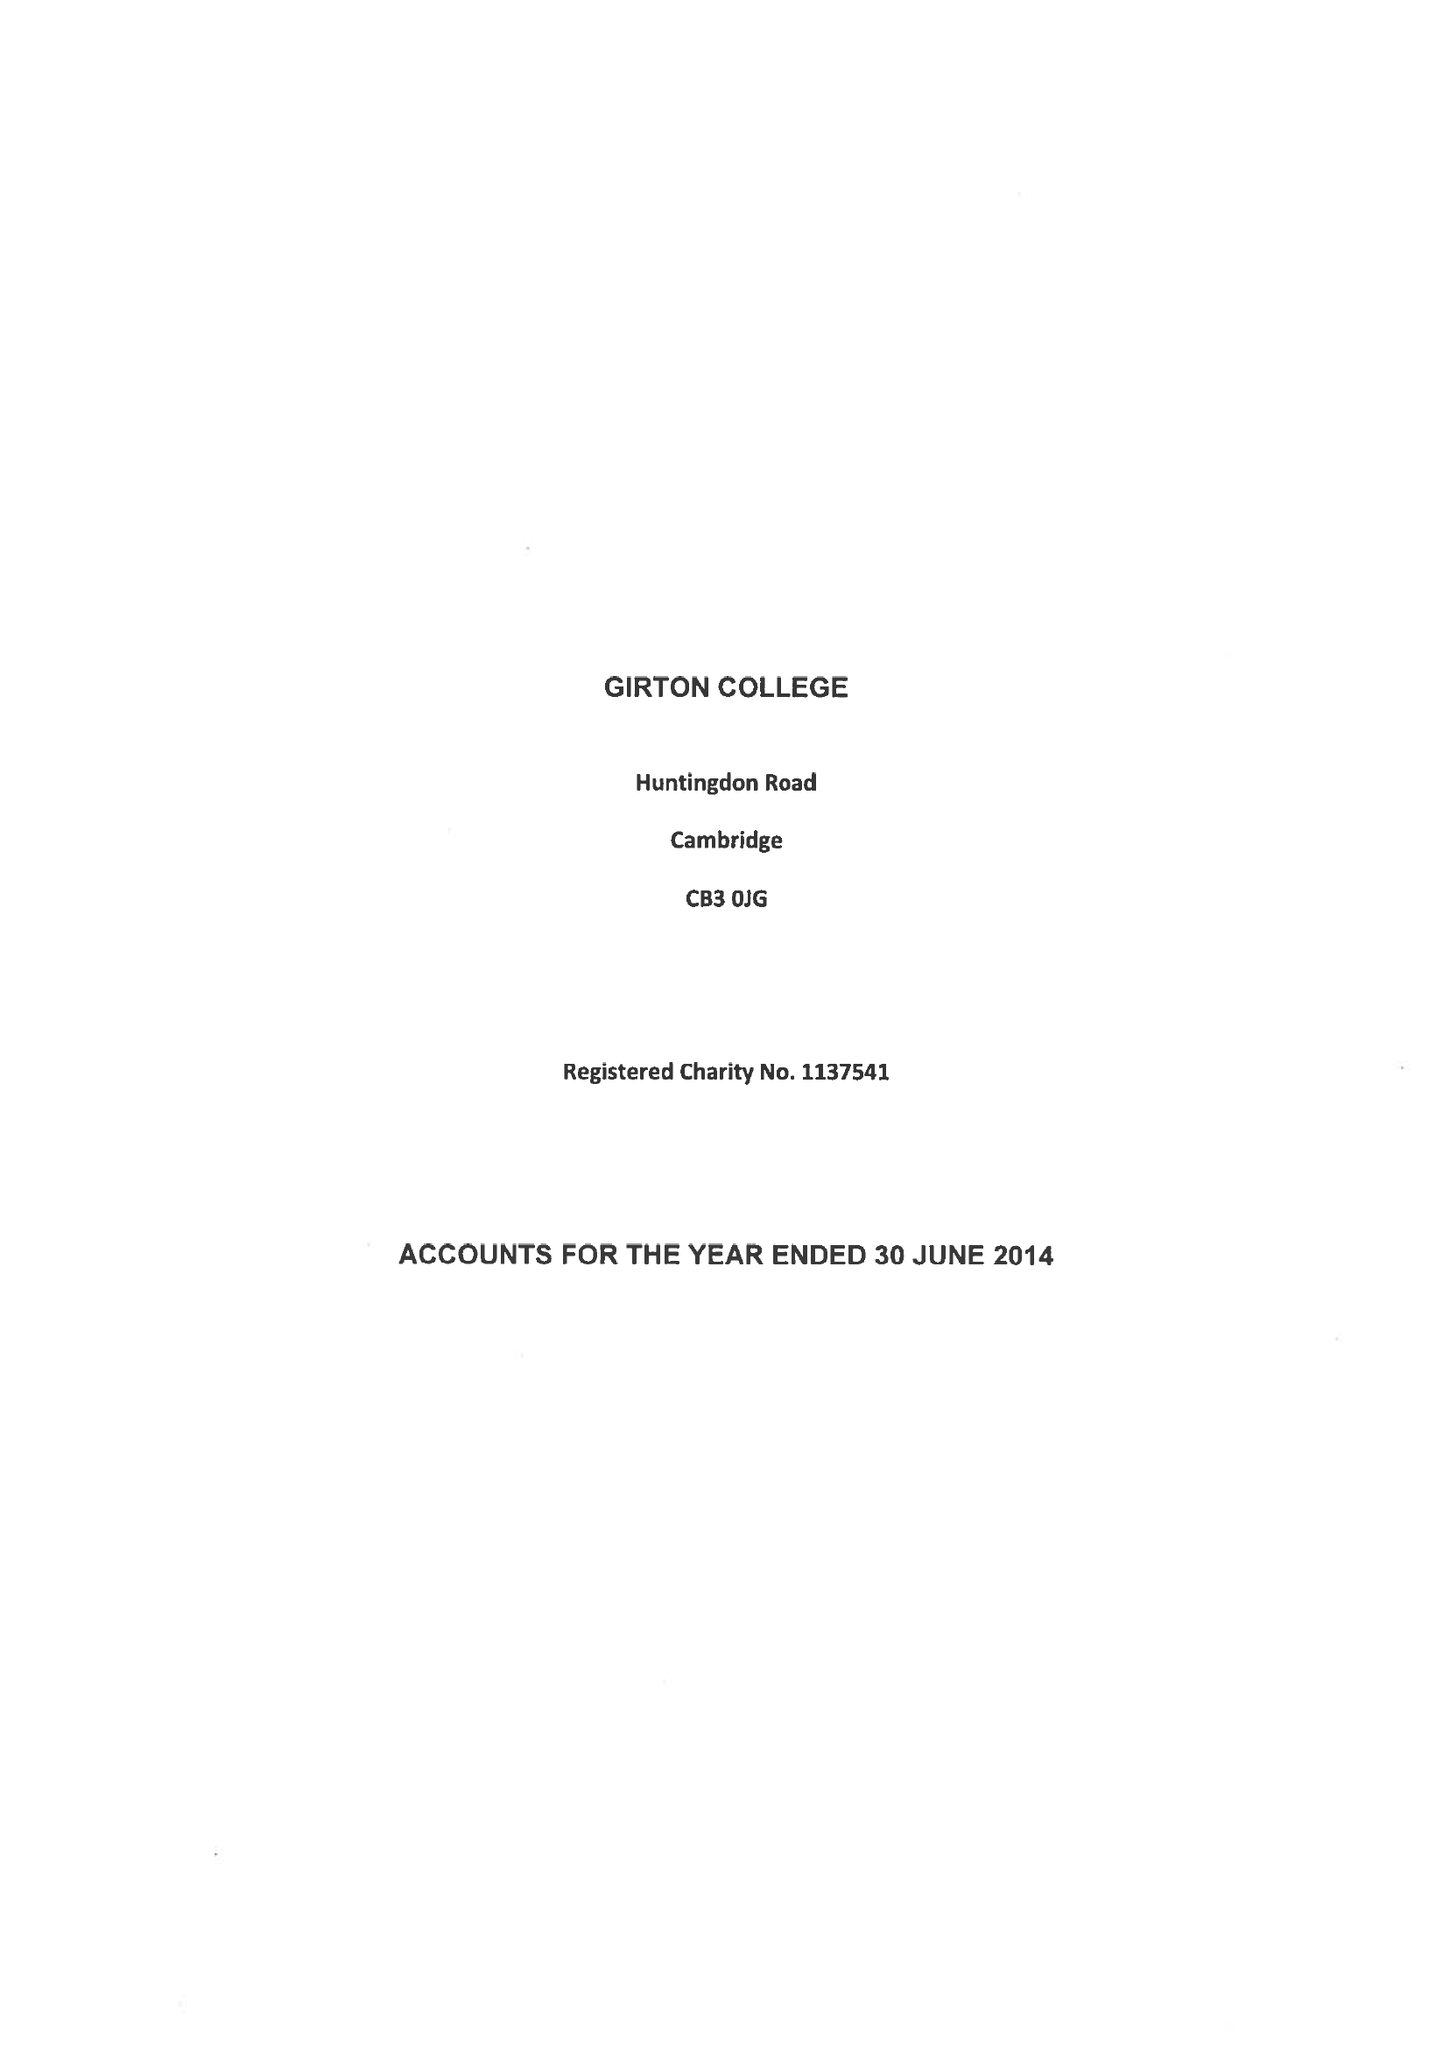What is the value for the address__postcode?
Answer the question using a single word or phrase. CB3 0JG 